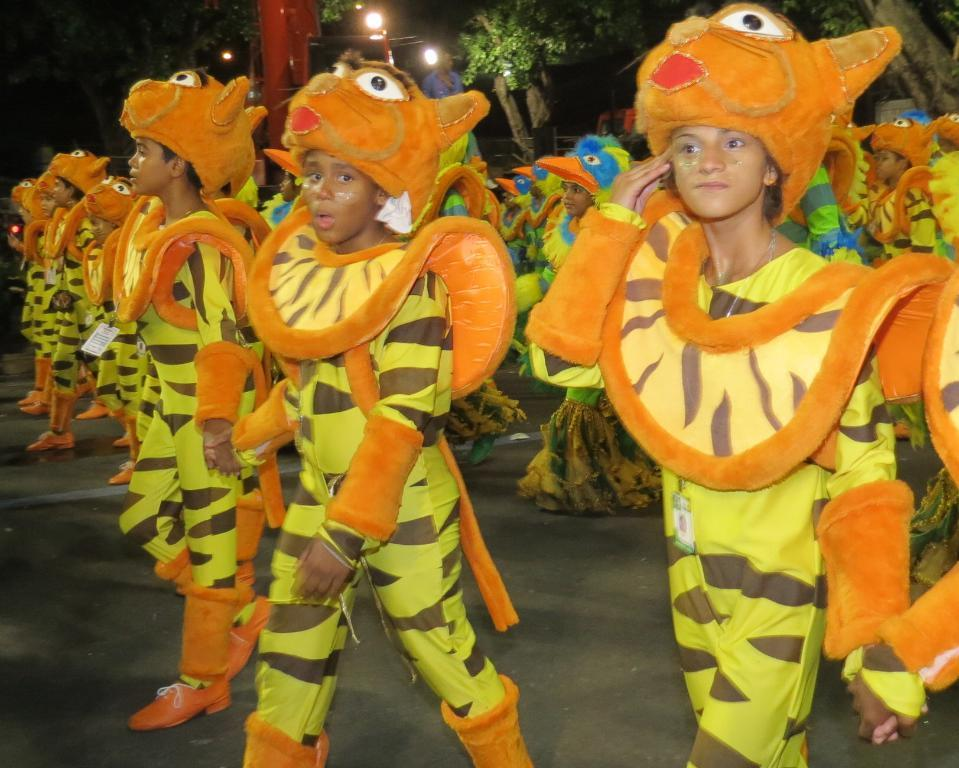How many people are in the image? There are people in the image, but the exact number is not specified. What are the people wearing? The people are wearing the same dress. What are the people doing in the image? The people are walking on a road. What can be seen in the background of the image? There are lights and trees in the background of the image. What is the color of the pole in the image? There is a red color pole in the image. What theory is being discussed by the people in the image? There is no indication in the image that the people are discussing any theory. Can you see any quince in the image? There is no mention of quince in the image, so it cannot be determined if any are present. 